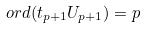Convert formula to latex. <formula><loc_0><loc_0><loc_500><loc_500>o r d ( t _ { p + 1 } U _ { p + 1 } ) = p</formula> 